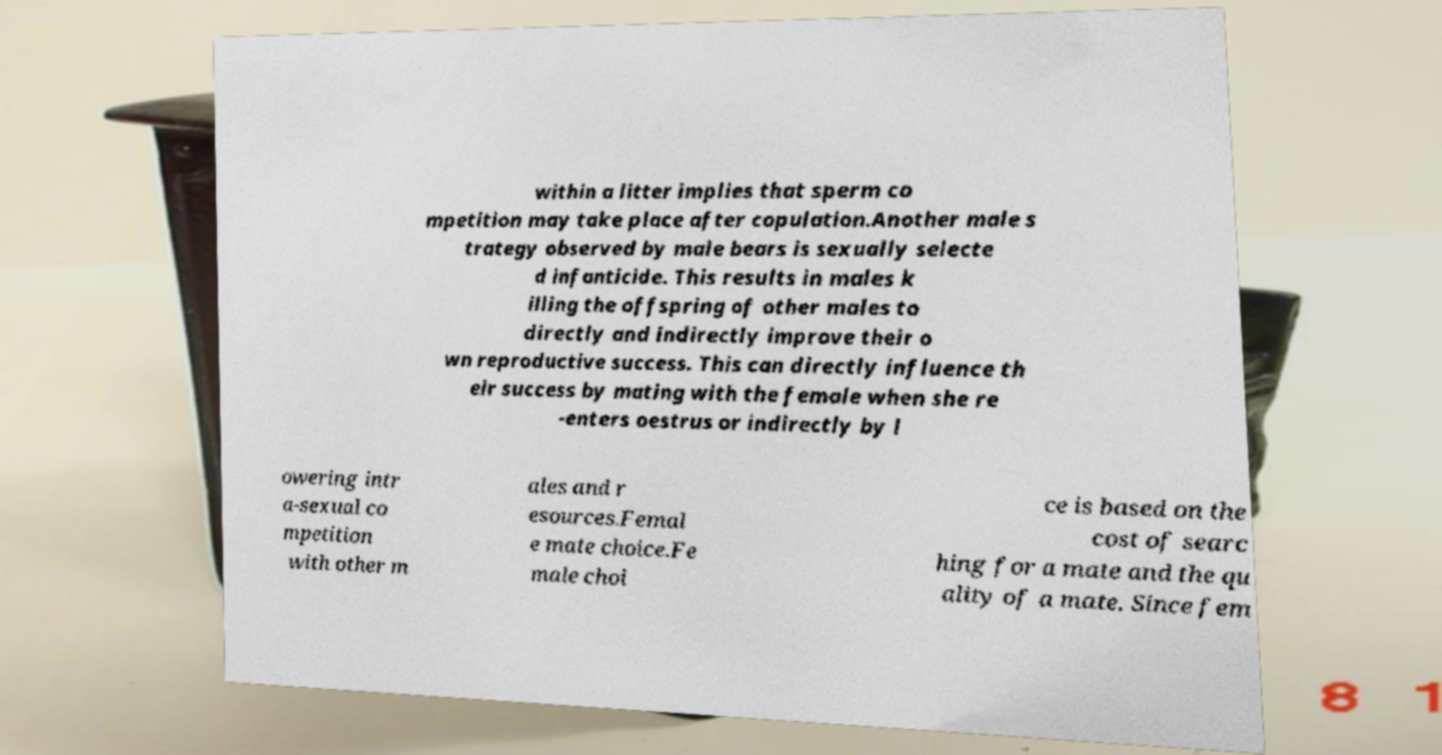There's text embedded in this image that I need extracted. Can you transcribe it verbatim? within a litter implies that sperm co mpetition may take place after copulation.Another male s trategy observed by male bears is sexually selecte d infanticide. This results in males k illing the offspring of other males to directly and indirectly improve their o wn reproductive success. This can directly influence th eir success by mating with the female when she re -enters oestrus or indirectly by l owering intr a-sexual co mpetition with other m ales and r esources.Femal e mate choice.Fe male choi ce is based on the cost of searc hing for a mate and the qu ality of a mate. Since fem 